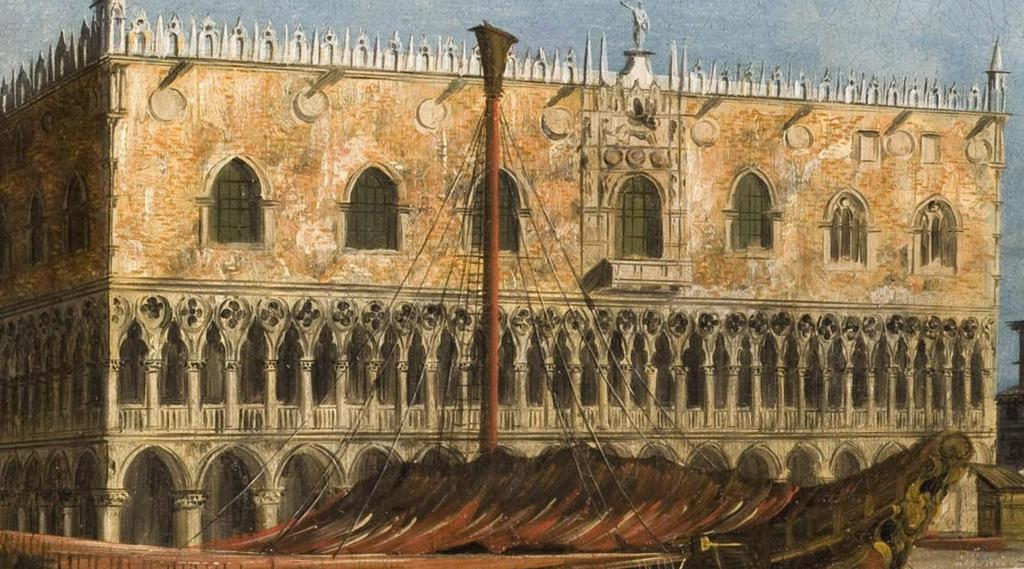What type of structure is visible in the image? There is a building in the image. What feature can be seen on the building? The building has windows. What else is present in the image besides the building? There is a pole with ropes in the image. What is the size of the son in the image? There is no son present in the image, so it is not possible to determine the size of a son. 